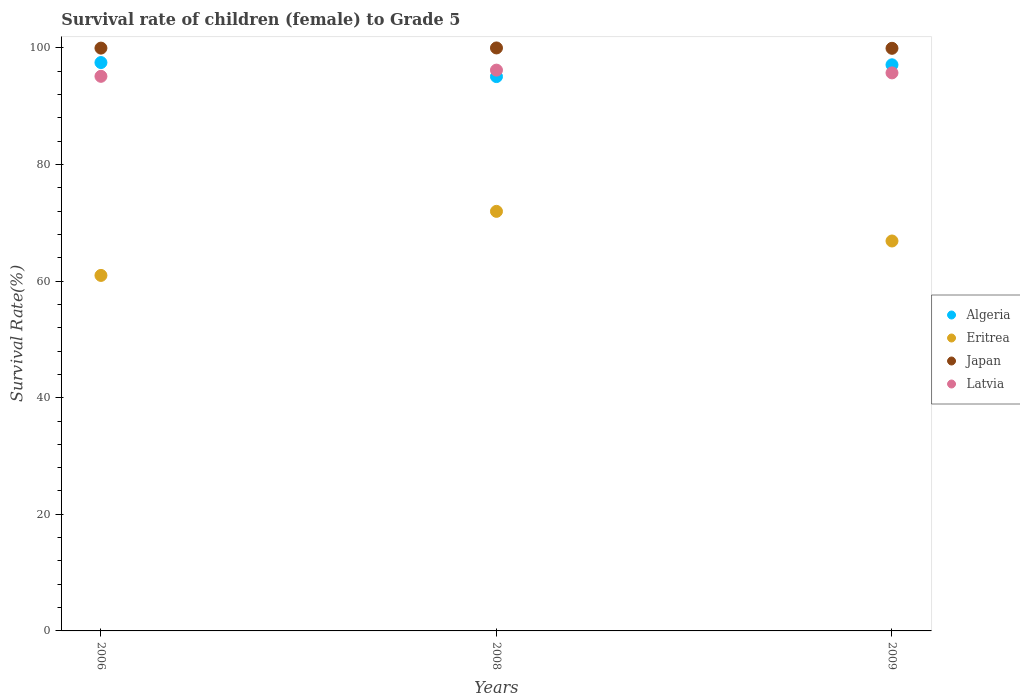What is the survival rate of female children to grade 5 in Eritrea in 2009?
Make the answer very short. 66.88. Across all years, what is the maximum survival rate of female children to grade 5 in Algeria?
Provide a short and direct response. 97.49. Across all years, what is the minimum survival rate of female children to grade 5 in Japan?
Make the answer very short. 99.93. In which year was the survival rate of female children to grade 5 in Latvia maximum?
Make the answer very short. 2008. What is the total survival rate of female children to grade 5 in Eritrea in the graph?
Give a very brief answer. 199.83. What is the difference between the survival rate of female children to grade 5 in Eritrea in 2008 and that in 2009?
Offer a very short reply. 5.08. What is the difference between the survival rate of female children to grade 5 in Japan in 2006 and the survival rate of female children to grade 5 in Latvia in 2009?
Provide a succinct answer. 4.25. What is the average survival rate of female children to grade 5 in Algeria per year?
Keep it short and to the point. 96.56. In the year 2008, what is the difference between the survival rate of female children to grade 5 in Japan and survival rate of female children to grade 5 in Latvia?
Give a very brief answer. 3.8. In how many years, is the survival rate of female children to grade 5 in Japan greater than 56 %?
Ensure brevity in your answer.  3. What is the ratio of the survival rate of female children to grade 5 in Japan in 2006 to that in 2009?
Provide a succinct answer. 1. Is the survival rate of female children to grade 5 in Eritrea in 2008 less than that in 2009?
Give a very brief answer. No. What is the difference between the highest and the second highest survival rate of female children to grade 5 in Eritrea?
Keep it short and to the point. 5.08. What is the difference between the highest and the lowest survival rate of female children to grade 5 in Latvia?
Keep it short and to the point. 1.06. In how many years, is the survival rate of female children to grade 5 in Algeria greater than the average survival rate of female children to grade 5 in Algeria taken over all years?
Your answer should be compact. 2. Is the sum of the survival rate of female children to grade 5 in Eritrea in 2006 and 2009 greater than the maximum survival rate of female children to grade 5 in Japan across all years?
Your response must be concise. Yes. Is it the case that in every year, the sum of the survival rate of female children to grade 5 in Latvia and survival rate of female children to grade 5 in Algeria  is greater than the sum of survival rate of female children to grade 5 in Eritrea and survival rate of female children to grade 5 in Japan?
Give a very brief answer. No. Does the survival rate of female children to grade 5 in Latvia monotonically increase over the years?
Give a very brief answer. No. Is the survival rate of female children to grade 5 in Latvia strictly greater than the survival rate of female children to grade 5 in Japan over the years?
Keep it short and to the point. No. Is the survival rate of female children to grade 5 in Eritrea strictly less than the survival rate of female children to grade 5 in Algeria over the years?
Provide a short and direct response. Yes. How many years are there in the graph?
Your answer should be very brief. 3. What is the difference between two consecutive major ticks on the Y-axis?
Offer a terse response. 20. Does the graph contain any zero values?
Make the answer very short. No. How many legend labels are there?
Your answer should be compact. 4. How are the legend labels stacked?
Your answer should be very brief. Vertical. What is the title of the graph?
Your answer should be very brief. Survival rate of children (female) to Grade 5. Does "Myanmar" appear as one of the legend labels in the graph?
Make the answer very short. No. What is the label or title of the X-axis?
Offer a terse response. Years. What is the label or title of the Y-axis?
Offer a very short reply. Survival Rate(%). What is the Survival Rate(%) of Algeria in 2006?
Your response must be concise. 97.49. What is the Survival Rate(%) in Eritrea in 2006?
Keep it short and to the point. 60.98. What is the Survival Rate(%) of Japan in 2006?
Offer a terse response. 99.97. What is the Survival Rate(%) of Latvia in 2006?
Give a very brief answer. 95.13. What is the Survival Rate(%) in Algeria in 2008?
Provide a short and direct response. 95.08. What is the Survival Rate(%) of Eritrea in 2008?
Provide a succinct answer. 71.96. What is the Survival Rate(%) of Japan in 2008?
Provide a succinct answer. 99.99. What is the Survival Rate(%) of Latvia in 2008?
Your response must be concise. 96.19. What is the Survival Rate(%) in Algeria in 2009?
Ensure brevity in your answer.  97.1. What is the Survival Rate(%) in Eritrea in 2009?
Keep it short and to the point. 66.88. What is the Survival Rate(%) in Japan in 2009?
Offer a very short reply. 99.93. What is the Survival Rate(%) of Latvia in 2009?
Your answer should be compact. 95.72. Across all years, what is the maximum Survival Rate(%) in Algeria?
Give a very brief answer. 97.49. Across all years, what is the maximum Survival Rate(%) in Eritrea?
Provide a succinct answer. 71.96. Across all years, what is the maximum Survival Rate(%) in Japan?
Provide a short and direct response. 99.99. Across all years, what is the maximum Survival Rate(%) in Latvia?
Your response must be concise. 96.19. Across all years, what is the minimum Survival Rate(%) of Algeria?
Offer a very short reply. 95.08. Across all years, what is the minimum Survival Rate(%) in Eritrea?
Ensure brevity in your answer.  60.98. Across all years, what is the minimum Survival Rate(%) of Japan?
Offer a very short reply. 99.93. Across all years, what is the minimum Survival Rate(%) of Latvia?
Your answer should be compact. 95.13. What is the total Survival Rate(%) in Algeria in the graph?
Provide a succinct answer. 289.67. What is the total Survival Rate(%) of Eritrea in the graph?
Make the answer very short. 199.83. What is the total Survival Rate(%) of Japan in the graph?
Provide a short and direct response. 299.89. What is the total Survival Rate(%) of Latvia in the graph?
Make the answer very short. 287.03. What is the difference between the Survival Rate(%) in Algeria in 2006 and that in 2008?
Give a very brief answer. 2.41. What is the difference between the Survival Rate(%) in Eritrea in 2006 and that in 2008?
Provide a short and direct response. -10.99. What is the difference between the Survival Rate(%) of Japan in 2006 and that in 2008?
Make the answer very short. -0.03. What is the difference between the Survival Rate(%) in Latvia in 2006 and that in 2008?
Keep it short and to the point. -1.06. What is the difference between the Survival Rate(%) of Algeria in 2006 and that in 2009?
Keep it short and to the point. 0.38. What is the difference between the Survival Rate(%) in Eritrea in 2006 and that in 2009?
Provide a short and direct response. -5.91. What is the difference between the Survival Rate(%) in Japan in 2006 and that in 2009?
Provide a succinct answer. 0.03. What is the difference between the Survival Rate(%) in Latvia in 2006 and that in 2009?
Provide a succinct answer. -0.59. What is the difference between the Survival Rate(%) of Algeria in 2008 and that in 2009?
Your answer should be very brief. -2.02. What is the difference between the Survival Rate(%) in Eritrea in 2008 and that in 2009?
Provide a succinct answer. 5.08. What is the difference between the Survival Rate(%) of Japan in 2008 and that in 2009?
Offer a very short reply. 0.06. What is the difference between the Survival Rate(%) of Latvia in 2008 and that in 2009?
Offer a very short reply. 0.47. What is the difference between the Survival Rate(%) of Algeria in 2006 and the Survival Rate(%) of Eritrea in 2008?
Keep it short and to the point. 25.52. What is the difference between the Survival Rate(%) of Algeria in 2006 and the Survival Rate(%) of Japan in 2008?
Your response must be concise. -2.51. What is the difference between the Survival Rate(%) of Algeria in 2006 and the Survival Rate(%) of Latvia in 2008?
Your answer should be very brief. 1.3. What is the difference between the Survival Rate(%) of Eritrea in 2006 and the Survival Rate(%) of Japan in 2008?
Keep it short and to the point. -39.02. What is the difference between the Survival Rate(%) of Eritrea in 2006 and the Survival Rate(%) of Latvia in 2008?
Your response must be concise. -35.21. What is the difference between the Survival Rate(%) in Japan in 2006 and the Survival Rate(%) in Latvia in 2008?
Give a very brief answer. 3.78. What is the difference between the Survival Rate(%) of Algeria in 2006 and the Survival Rate(%) of Eritrea in 2009?
Make the answer very short. 30.61. What is the difference between the Survival Rate(%) in Algeria in 2006 and the Survival Rate(%) in Japan in 2009?
Give a very brief answer. -2.44. What is the difference between the Survival Rate(%) in Algeria in 2006 and the Survival Rate(%) in Latvia in 2009?
Provide a succinct answer. 1.77. What is the difference between the Survival Rate(%) in Eritrea in 2006 and the Survival Rate(%) in Japan in 2009?
Give a very brief answer. -38.95. What is the difference between the Survival Rate(%) in Eritrea in 2006 and the Survival Rate(%) in Latvia in 2009?
Offer a very short reply. -34.74. What is the difference between the Survival Rate(%) of Japan in 2006 and the Survival Rate(%) of Latvia in 2009?
Provide a succinct answer. 4.25. What is the difference between the Survival Rate(%) of Algeria in 2008 and the Survival Rate(%) of Eritrea in 2009?
Provide a short and direct response. 28.2. What is the difference between the Survival Rate(%) of Algeria in 2008 and the Survival Rate(%) of Japan in 2009?
Offer a terse response. -4.85. What is the difference between the Survival Rate(%) in Algeria in 2008 and the Survival Rate(%) in Latvia in 2009?
Your answer should be very brief. -0.64. What is the difference between the Survival Rate(%) of Eritrea in 2008 and the Survival Rate(%) of Japan in 2009?
Ensure brevity in your answer.  -27.97. What is the difference between the Survival Rate(%) in Eritrea in 2008 and the Survival Rate(%) in Latvia in 2009?
Offer a terse response. -23.75. What is the difference between the Survival Rate(%) in Japan in 2008 and the Survival Rate(%) in Latvia in 2009?
Your response must be concise. 4.28. What is the average Survival Rate(%) of Algeria per year?
Your response must be concise. 96.56. What is the average Survival Rate(%) of Eritrea per year?
Keep it short and to the point. 66.61. What is the average Survival Rate(%) of Japan per year?
Ensure brevity in your answer.  99.96. What is the average Survival Rate(%) of Latvia per year?
Offer a terse response. 95.68. In the year 2006, what is the difference between the Survival Rate(%) in Algeria and Survival Rate(%) in Eritrea?
Provide a short and direct response. 36.51. In the year 2006, what is the difference between the Survival Rate(%) of Algeria and Survival Rate(%) of Japan?
Provide a short and direct response. -2.48. In the year 2006, what is the difference between the Survival Rate(%) in Algeria and Survival Rate(%) in Latvia?
Offer a very short reply. 2.36. In the year 2006, what is the difference between the Survival Rate(%) in Eritrea and Survival Rate(%) in Japan?
Your answer should be compact. -38.99. In the year 2006, what is the difference between the Survival Rate(%) in Eritrea and Survival Rate(%) in Latvia?
Give a very brief answer. -34.15. In the year 2006, what is the difference between the Survival Rate(%) in Japan and Survival Rate(%) in Latvia?
Provide a short and direct response. 4.84. In the year 2008, what is the difference between the Survival Rate(%) of Algeria and Survival Rate(%) of Eritrea?
Your answer should be very brief. 23.12. In the year 2008, what is the difference between the Survival Rate(%) in Algeria and Survival Rate(%) in Japan?
Your answer should be compact. -4.91. In the year 2008, what is the difference between the Survival Rate(%) of Algeria and Survival Rate(%) of Latvia?
Keep it short and to the point. -1.11. In the year 2008, what is the difference between the Survival Rate(%) in Eritrea and Survival Rate(%) in Japan?
Give a very brief answer. -28.03. In the year 2008, what is the difference between the Survival Rate(%) in Eritrea and Survival Rate(%) in Latvia?
Keep it short and to the point. -24.22. In the year 2008, what is the difference between the Survival Rate(%) in Japan and Survival Rate(%) in Latvia?
Make the answer very short. 3.8. In the year 2009, what is the difference between the Survival Rate(%) in Algeria and Survival Rate(%) in Eritrea?
Give a very brief answer. 30.22. In the year 2009, what is the difference between the Survival Rate(%) in Algeria and Survival Rate(%) in Japan?
Ensure brevity in your answer.  -2.83. In the year 2009, what is the difference between the Survival Rate(%) in Algeria and Survival Rate(%) in Latvia?
Provide a succinct answer. 1.39. In the year 2009, what is the difference between the Survival Rate(%) of Eritrea and Survival Rate(%) of Japan?
Offer a terse response. -33.05. In the year 2009, what is the difference between the Survival Rate(%) in Eritrea and Survival Rate(%) in Latvia?
Provide a succinct answer. -28.83. In the year 2009, what is the difference between the Survival Rate(%) in Japan and Survival Rate(%) in Latvia?
Keep it short and to the point. 4.21. What is the ratio of the Survival Rate(%) in Algeria in 2006 to that in 2008?
Provide a succinct answer. 1.03. What is the ratio of the Survival Rate(%) of Eritrea in 2006 to that in 2008?
Ensure brevity in your answer.  0.85. What is the ratio of the Survival Rate(%) of Japan in 2006 to that in 2008?
Your answer should be very brief. 1. What is the ratio of the Survival Rate(%) of Eritrea in 2006 to that in 2009?
Offer a very short reply. 0.91. What is the ratio of the Survival Rate(%) in Japan in 2006 to that in 2009?
Give a very brief answer. 1. What is the ratio of the Survival Rate(%) in Latvia in 2006 to that in 2009?
Offer a very short reply. 0.99. What is the ratio of the Survival Rate(%) of Algeria in 2008 to that in 2009?
Ensure brevity in your answer.  0.98. What is the ratio of the Survival Rate(%) of Eritrea in 2008 to that in 2009?
Ensure brevity in your answer.  1.08. What is the ratio of the Survival Rate(%) in Latvia in 2008 to that in 2009?
Provide a succinct answer. 1. What is the difference between the highest and the second highest Survival Rate(%) of Algeria?
Keep it short and to the point. 0.38. What is the difference between the highest and the second highest Survival Rate(%) of Eritrea?
Ensure brevity in your answer.  5.08. What is the difference between the highest and the second highest Survival Rate(%) of Japan?
Your answer should be compact. 0.03. What is the difference between the highest and the second highest Survival Rate(%) in Latvia?
Make the answer very short. 0.47. What is the difference between the highest and the lowest Survival Rate(%) in Algeria?
Give a very brief answer. 2.41. What is the difference between the highest and the lowest Survival Rate(%) in Eritrea?
Ensure brevity in your answer.  10.99. What is the difference between the highest and the lowest Survival Rate(%) of Japan?
Provide a succinct answer. 0.06. What is the difference between the highest and the lowest Survival Rate(%) of Latvia?
Ensure brevity in your answer.  1.06. 